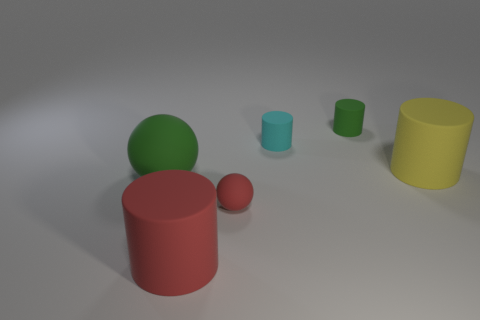How many objects are big things that are to the right of the green rubber cylinder or large cylinders?
Keep it short and to the point. 2. Are there any other big green things that have the same shape as the big green thing?
Provide a short and direct response. No. Are there an equal number of rubber spheres that are behind the green sphere and yellow blocks?
Your answer should be compact. Yes. There is a rubber thing that is the same color as the tiny sphere; what is its shape?
Provide a succinct answer. Cylinder. What number of red balls are the same size as the red cylinder?
Provide a short and direct response. 0. How many tiny cyan matte objects are on the left side of the large yellow thing?
Offer a terse response. 1. Is there a big object that has the same color as the small sphere?
Offer a terse response. Yes. What is the size of the cyan thing that is the same material as the yellow object?
Your response must be concise. Small. The rubber object that is on the left side of the big red cylinder is what color?
Offer a terse response. Green. Is there a red object that is to the left of the green rubber object to the right of the large cylinder that is left of the small green rubber object?
Your response must be concise. Yes. 